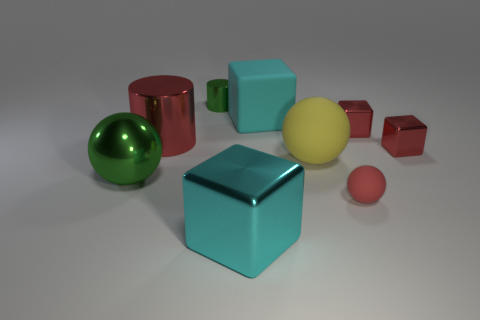Subtract all big red cylinders. Subtract all small green cylinders. How many objects are left? 7 Add 4 red shiny objects. How many red shiny objects are left? 7 Add 6 tiny red things. How many tiny red things exist? 9 Subtract 0 brown cylinders. How many objects are left? 9 Subtract all balls. How many objects are left? 6 Subtract all blue spheres. Subtract all yellow cylinders. How many spheres are left? 3 